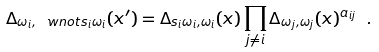<formula> <loc_0><loc_0><loc_500><loc_500>\Delta _ { \omega _ { i } , \ w n o t s _ { i } \omega _ { i } } ( x ^ { \prime } ) = \Delta _ { s _ { i } \omega _ { i } , \omega _ { i } } ( x ) \prod _ { j \neq i } \Delta _ { \omega _ { j } , \omega _ { j } } ( x ) ^ { a _ { i j } } \ .</formula> 